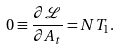Convert formula to latex. <formula><loc_0><loc_0><loc_500><loc_500>0 \equiv \frac { \partial \mathcal { L } } { \partial A _ { t } } = N T _ { 1 } .</formula> 